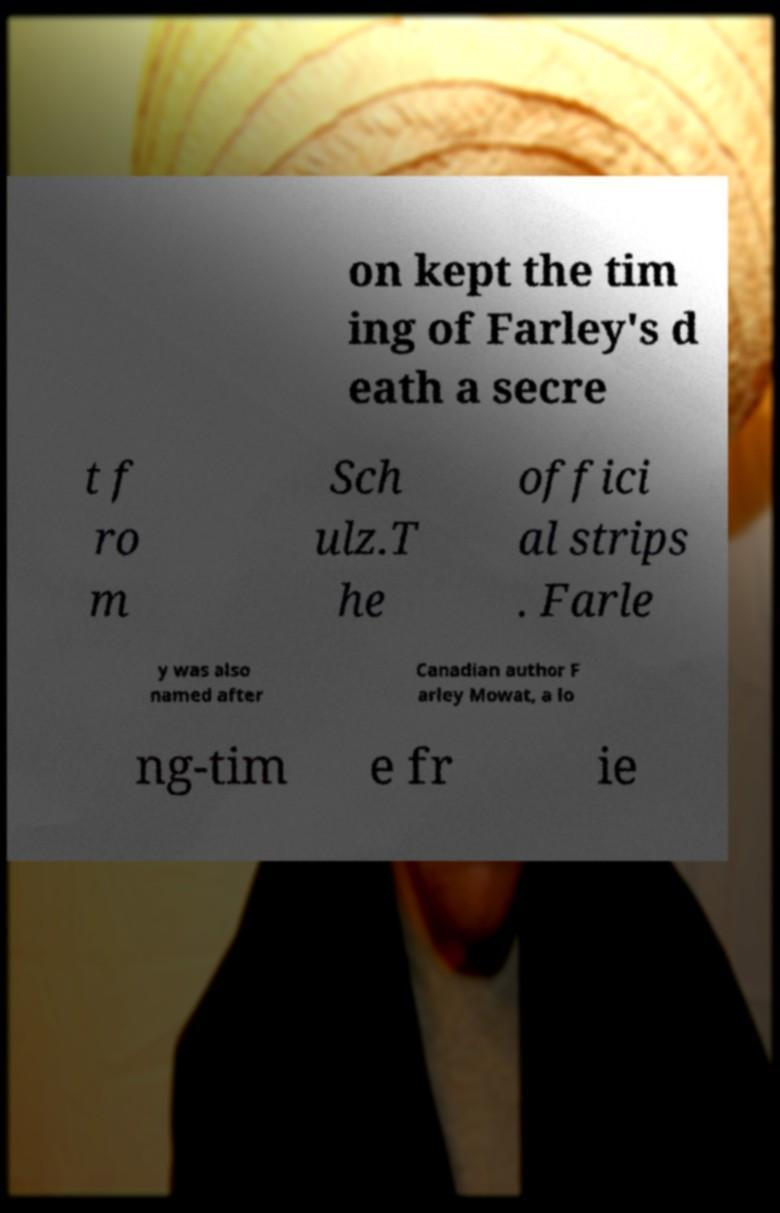Can you accurately transcribe the text from the provided image for me? on kept the tim ing of Farley's d eath a secre t f ro m Sch ulz.T he offici al strips . Farle y was also named after Canadian author F arley Mowat, a lo ng-tim e fr ie 